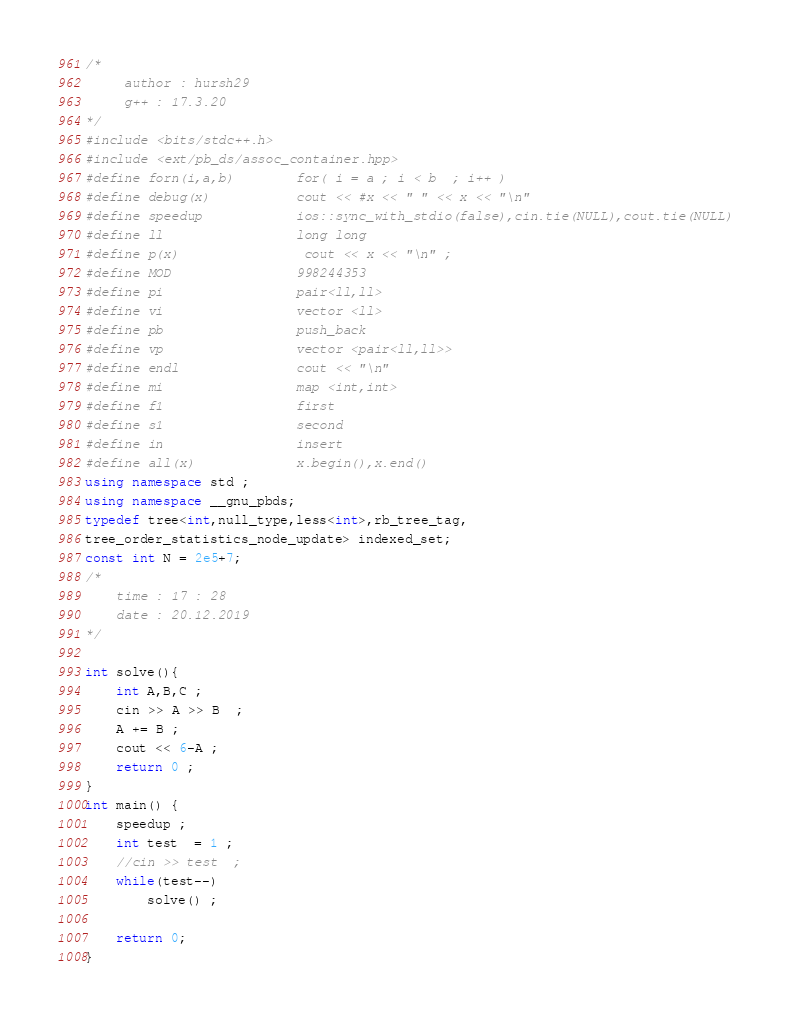<code> <loc_0><loc_0><loc_500><loc_500><_C++_>/*  
     author : hursh29    
     g++ : 17.3.20 
*/        
#include <bits/stdc++.h>
#include <ext/pb_ds/assoc_container.hpp>
#define forn(i,a,b)        for( i = a ; i < b  ; i++ )
#define debug(x)           cout << #x << " " << x << "\n"
#define speedup            ios::sync_with_stdio(false),cin.tie(NULL),cout.tie(NULL)
#define ll                 long long  
#define p(x) 			   cout << x << "\n" ; 
#define MOD                998244353
#define pi                 pair<ll,ll>
#define vi                 vector <ll>
#define pb                 push_back
#define vp                 vector <pair<ll,ll>>
#define endl               cout << "\n"
#define mi                 map <int,int> 
#define f1                 first 
#define s1                 second    
#define in                 insert
#define all(x)             x.begin(),x.end() 
using namespace std ; 
using namespace __gnu_pbds;
typedef tree<int,null_type,less<int>,rb_tree_tag,
tree_order_statistics_node_update> indexed_set; 
const int N = 2e5+7; 
/*   
    time : 17 : 28      
    date : 20.12.2019
*/    

int solve(){ 
	int A,B,C ;
	cin >> A >> B  ;
	A += B ;  
	cout << 6-A ; 
    return 0 ; 
}
int main() { 
	speedup ;  
    int test  = 1 ; 
	//cin >> test  ; 
	while(test--)
    	solve() ; 
	 
	return 0;
} 
</code> 